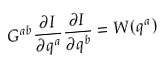<formula> <loc_0><loc_0><loc_500><loc_500>G ^ { a b } \frac { \partial I } { \partial q ^ { a } } \frac { \partial I } { \partial q ^ { b } } = W ( q ^ { a } )</formula> 